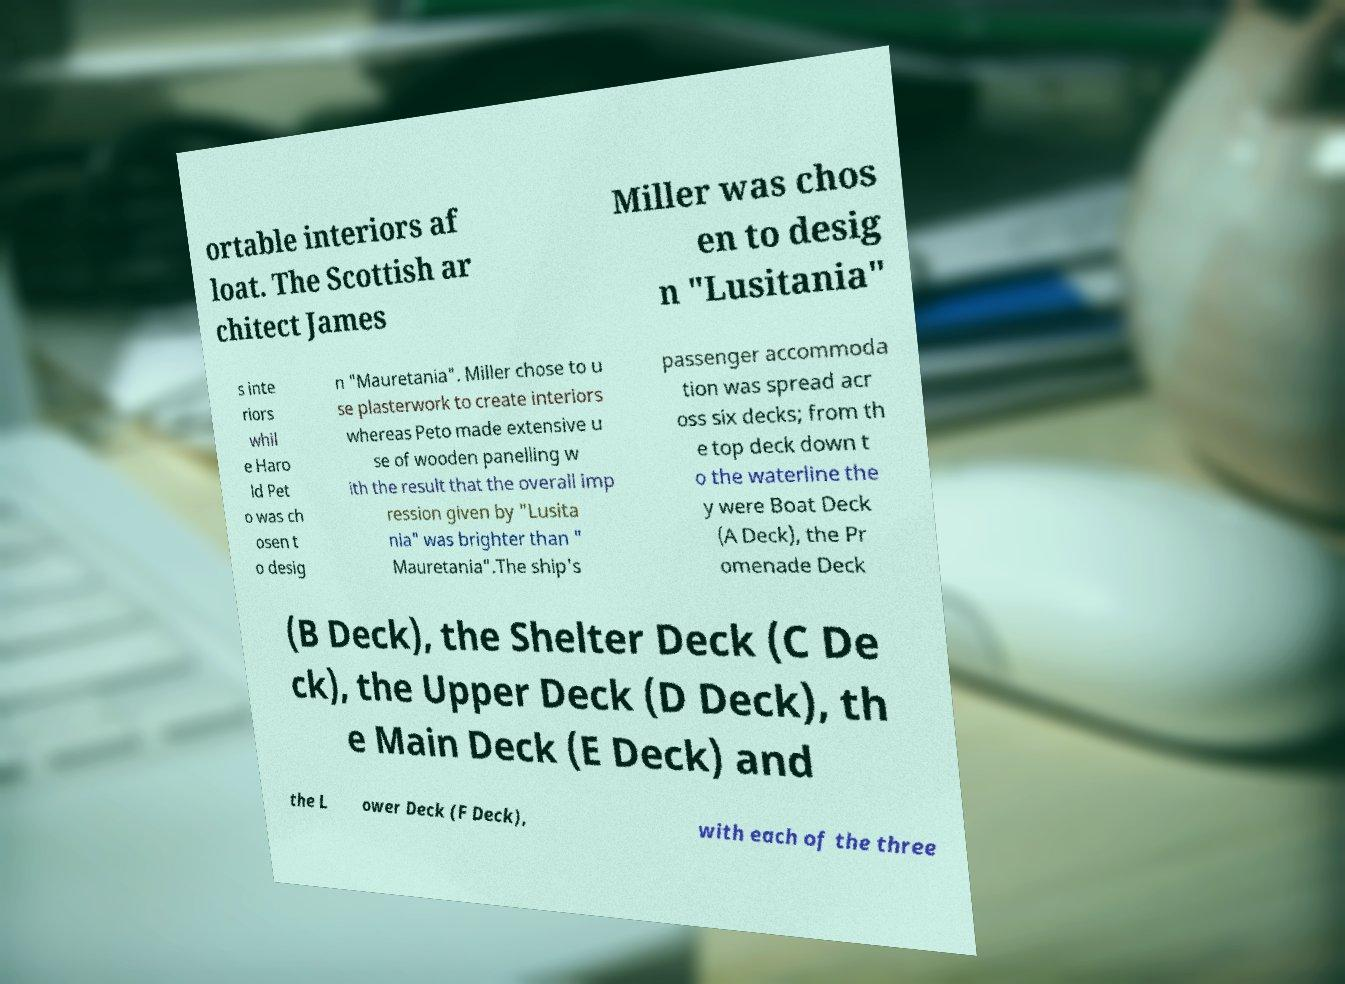What messages or text are displayed in this image? I need them in a readable, typed format. ortable interiors af loat. The Scottish ar chitect James Miller was chos en to desig n "Lusitania" s inte riors whil e Haro ld Pet o was ch osen t o desig n "Mauretania". Miller chose to u se plasterwork to create interiors whereas Peto made extensive u se of wooden panelling w ith the result that the overall imp ression given by "Lusita nia" was brighter than " Mauretania".The ship's passenger accommoda tion was spread acr oss six decks; from th e top deck down t o the waterline the y were Boat Deck (A Deck), the Pr omenade Deck (B Deck), the Shelter Deck (C De ck), the Upper Deck (D Deck), th e Main Deck (E Deck) and the L ower Deck (F Deck), with each of the three 